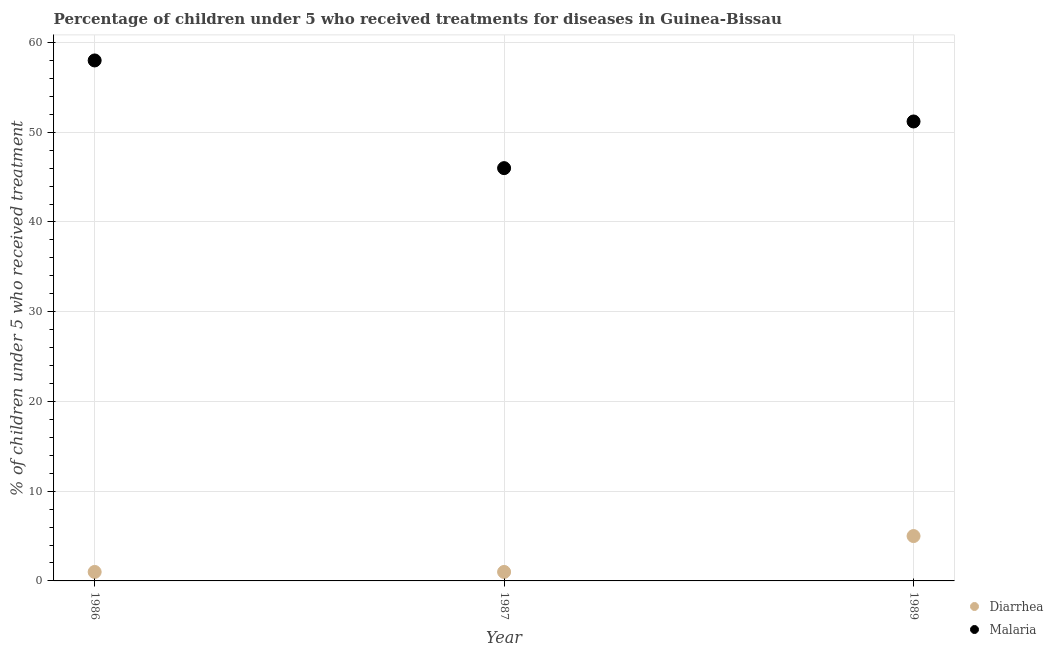Across all years, what is the minimum percentage of children who received treatment for malaria?
Your answer should be compact. 46. In which year was the percentage of children who received treatment for diarrhoea maximum?
Give a very brief answer. 1989. What is the total percentage of children who received treatment for malaria in the graph?
Your answer should be very brief. 155.2. What is the difference between the percentage of children who received treatment for malaria in 1987 and that in 1989?
Make the answer very short. -5.2. What is the difference between the percentage of children who received treatment for malaria in 1989 and the percentage of children who received treatment for diarrhoea in 1987?
Make the answer very short. 50.2. What is the average percentage of children who received treatment for diarrhoea per year?
Make the answer very short. 2.33. In the year 1986, what is the difference between the percentage of children who received treatment for malaria and percentage of children who received treatment for diarrhoea?
Ensure brevity in your answer.  57. In how many years, is the percentage of children who received treatment for malaria greater than 8 %?
Ensure brevity in your answer.  3. Is the percentage of children who received treatment for malaria in 1986 less than that in 1989?
Your answer should be compact. No. Is the difference between the percentage of children who received treatment for malaria in 1986 and 1987 greater than the difference between the percentage of children who received treatment for diarrhoea in 1986 and 1987?
Provide a succinct answer. Yes. What is the difference between the highest and the second highest percentage of children who received treatment for diarrhoea?
Keep it short and to the point. 4. What is the difference between the highest and the lowest percentage of children who received treatment for diarrhoea?
Make the answer very short. 4. Is the percentage of children who received treatment for diarrhoea strictly less than the percentage of children who received treatment for malaria over the years?
Your answer should be compact. Yes. How many dotlines are there?
Ensure brevity in your answer.  2. How many years are there in the graph?
Offer a very short reply. 3. What is the difference between two consecutive major ticks on the Y-axis?
Keep it short and to the point. 10. Are the values on the major ticks of Y-axis written in scientific E-notation?
Your response must be concise. No. Does the graph contain any zero values?
Make the answer very short. No. Does the graph contain grids?
Keep it short and to the point. Yes. How are the legend labels stacked?
Offer a very short reply. Vertical. What is the title of the graph?
Provide a short and direct response. Percentage of children under 5 who received treatments for diseases in Guinea-Bissau. What is the label or title of the Y-axis?
Your answer should be compact. % of children under 5 who received treatment. What is the % of children under 5 who received treatment in Diarrhea in 1986?
Give a very brief answer. 1. What is the % of children under 5 who received treatment of Diarrhea in 1987?
Your answer should be compact. 1. What is the % of children under 5 who received treatment of Diarrhea in 1989?
Provide a short and direct response. 5. What is the % of children under 5 who received treatment in Malaria in 1989?
Provide a short and direct response. 51.2. Across all years, what is the maximum % of children under 5 who received treatment of Diarrhea?
Give a very brief answer. 5. Across all years, what is the maximum % of children under 5 who received treatment in Malaria?
Your answer should be compact. 58. Across all years, what is the minimum % of children under 5 who received treatment of Malaria?
Ensure brevity in your answer.  46. What is the total % of children under 5 who received treatment in Malaria in the graph?
Give a very brief answer. 155.2. What is the difference between the % of children under 5 who received treatment of Malaria in 1986 and that in 1987?
Keep it short and to the point. 12. What is the difference between the % of children under 5 who received treatment in Diarrhea in 1986 and that in 1989?
Your answer should be very brief. -4. What is the difference between the % of children under 5 who received treatment in Diarrhea in 1987 and that in 1989?
Make the answer very short. -4. What is the difference between the % of children under 5 who received treatment in Malaria in 1987 and that in 1989?
Give a very brief answer. -5.2. What is the difference between the % of children under 5 who received treatment in Diarrhea in 1986 and the % of children under 5 who received treatment in Malaria in 1987?
Your response must be concise. -45. What is the difference between the % of children under 5 who received treatment of Diarrhea in 1986 and the % of children under 5 who received treatment of Malaria in 1989?
Provide a short and direct response. -50.2. What is the difference between the % of children under 5 who received treatment of Diarrhea in 1987 and the % of children under 5 who received treatment of Malaria in 1989?
Offer a very short reply. -50.2. What is the average % of children under 5 who received treatment of Diarrhea per year?
Keep it short and to the point. 2.33. What is the average % of children under 5 who received treatment of Malaria per year?
Provide a short and direct response. 51.73. In the year 1986, what is the difference between the % of children under 5 who received treatment in Diarrhea and % of children under 5 who received treatment in Malaria?
Keep it short and to the point. -57. In the year 1987, what is the difference between the % of children under 5 who received treatment in Diarrhea and % of children under 5 who received treatment in Malaria?
Offer a terse response. -45. In the year 1989, what is the difference between the % of children under 5 who received treatment of Diarrhea and % of children under 5 who received treatment of Malaria?
Make the answer very short. -46.2. What is the ratio of the % of children under 5 who received treatment in Malaria in 1986 to that in 1987?
Offer a terse response. 1.26. What is the ratio of the % of children under 5 who received treatment in Malaria in 1986 to that in 1989?
Your response must be concise. 1.13. What is the ratio of the % of children under 5 who received treatment of Diarrhea in 1987 to that in 1989?
Provide a short and direct response. 0.2. What is the ratio of the % of children under 5 who received treatment in Malaria in 1987 to that in 1989?
Provide a succinct answer. 0.9. What is the difference between the highest and the second highest % of children under 5 who received treatment in Diarrhea?
Your answer should be compact. 4. What is the difference between the highest and the second highest % of children under 5 who received treatment of Malaria?
Provide a short and direct response. 6.8. What is the difference between the highest and the lowest % of children under 5 who received treatment in Diarrhea?
Ensure brevity in your answer.  4. What is the difference between the highest and the lowest % of children under 5 who received treatment in Malaria?
Keep it short and to the point. 12. 